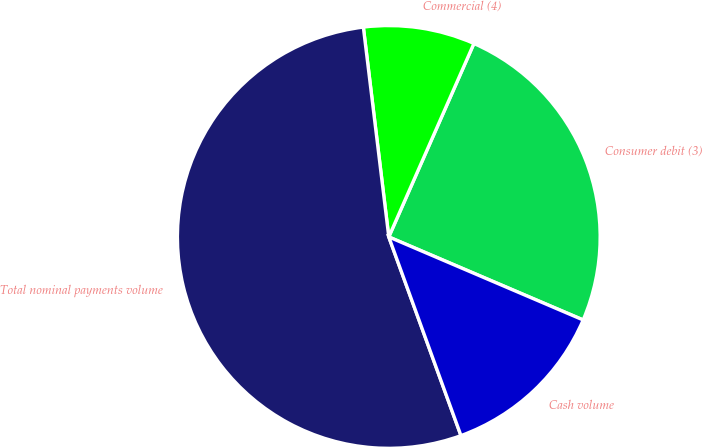Convert chart to OTSL. <chart><loc_0><loc_0><loc_500><loc_500><pie_chart><fcel>Consumer debit (3)<fcel>Commercial (4)<fcel>Total nominal payments volume<fcel>Cash volume<nl><fcel>24.83%<fcel>8.52%<fcel>53.63%<fcel>13.03%<nl></chart> 